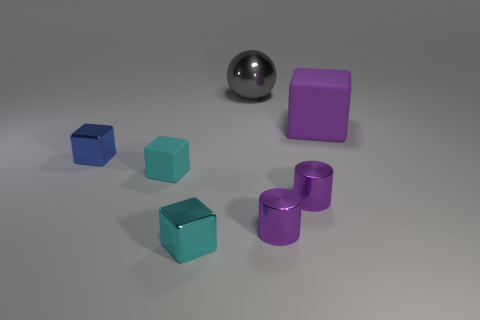What number of shiny cylinders have the same color as the big block?
Make the answer very short. 2. What size is the other block that is the same color as the small rubber block?
Ensure brevity in your answer.  Small. There is a matte thing to the right of the small cyan metal object; is its shape the same as the cyan shiny thing?
Your answer should be compact. Yes. What number of things are both behind the big purple thing and in front of the big gray shiny ball?
Offer a very short reply. 0. What material is the large cube?
Offer a very short reply. Rubber. Are there any other things that are the same color as the metal sphere?
Keep it short and to the point. No. Does the blue cube have the same material as the large purple block?
Your answer should be compact. No. What number of tiny blue things are in front of the cyan metal thing on the right side of the small blue block that is in front of the large gray shiny ball?
Keep it short and to the point. 0. What number of big cyan metal cubes are there?
Your answer should be compact. 0. Is the number of metallic cylinders on the left side of the small blue object less than the number of small cyan objects that are right of the big shiny thing?
Offer a very short reply. No. 